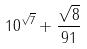Convert formula to latex. <formula><loc_0><loc_0><loc_500><loc_500>1 0 ^ { \sqrt { 7 } } + \frac { \sqrt { 8 } } { 9 1 }</formula> 